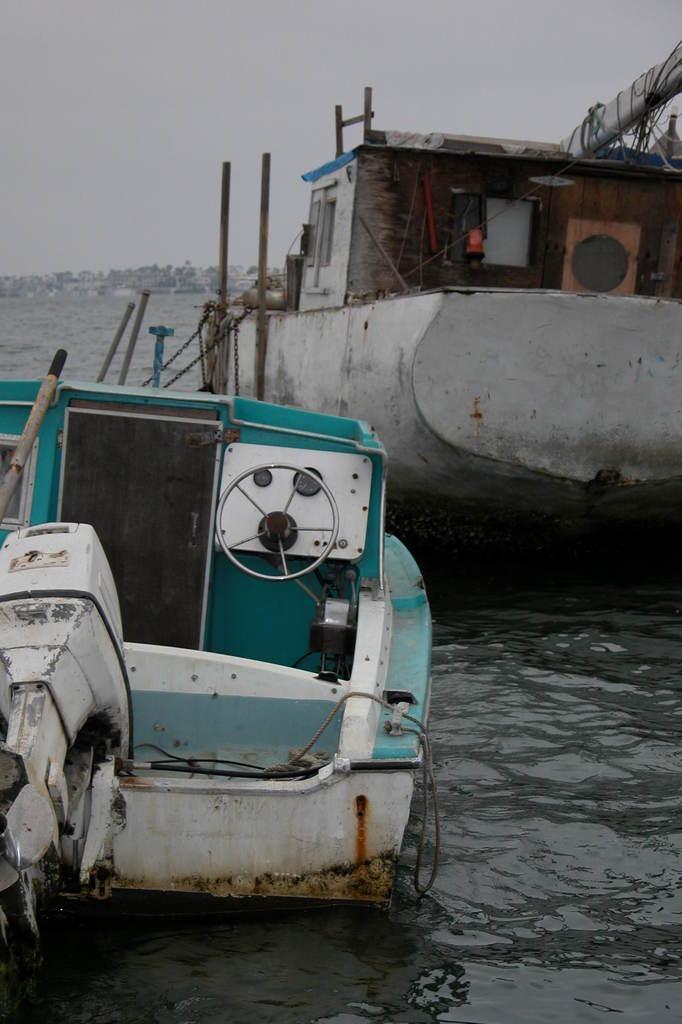Please provide a concise description of this image. In this image there are two boats in the water. On the left side there is a boat to which there is a steering. At the bottom left side there is a motor. On the right side top there is a house in the boat. In the background there are buildings. At the top there is the sky. On the right side top there are ropes tied to the pole. 